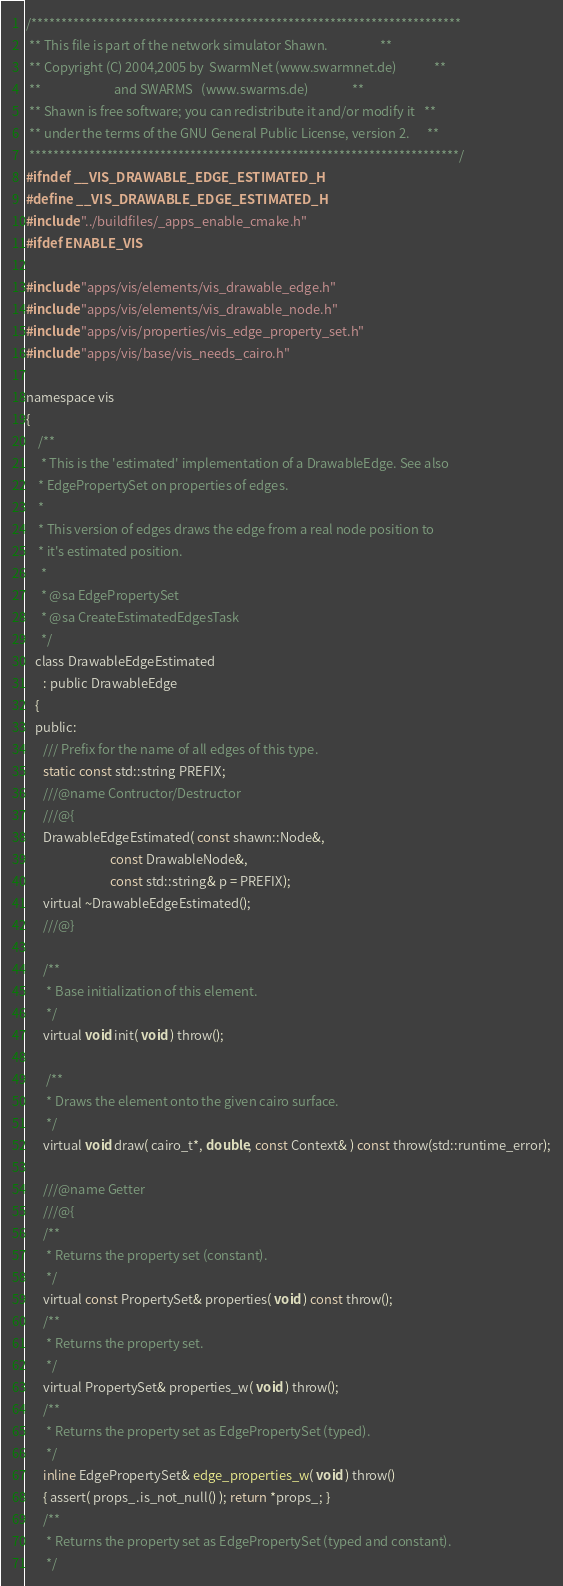Convert code to text. <code><loc_0><loc_0><loc_500><loc_500><_C_>/************************************************************************
 ** This file is part of the network simulator Shawn.                  **
 ** Copyright (C) 2004,2005 by  SwarmNet (www.swarmnet.de)             **
 **                         and SWARMS   (www.swarms.de)               **
 ** Shawn is free software; you can redistribute it and/or modify it   **
 ** under the terms of the GNU General Public License, version 2.      **
 ************************************************************************/
#ifndef __VIS_DRAWABLE_EDGE_ESTIMATED_H
#define __VIS_DRAWABLE_EDGE_ESTIMATED_H
#include "../buildfiles/_apps_enable_cmake.h"
#ifdef ENABLE_VIS

#include "apps/vis/elements/vis_drawable_edge.h"
#include "apps/vis/elements/vis_drawable_node.h"
#include "apps/vis/properties/vis_edge_property_set.h"
#include "apps/vis/base/vis_needs_cairo.h"

namespace vis
{
	/**
	 * This is the 'estimated' implementation of a DrawableEdge. See also 
    * EdgePropertySet on properties of edges. 
    *
    * This version of edges draws the edge from a real node position to
    * it's estimated position.
	 *
	 * @sa EdgePropertySet
	 * @sa CreateEstimatedEdgesTask
	 */
   class DrawableEdgeEstimated
      : public DrawableEdge
   {
   public:
      /// Prefix for the name of all edges of this type.
      static const std::string PREFIX;
      ///@name Contructor/Destructor
      ///@{
      DrawableEdgeEstimated( const shawn::Node&,
                             const DrawableNode&,
                             const std::string& p = PREFIX);
      virtual ~DrawableEdgeEstimated();
      ///@}

      /**
       * Base initialization of this element.
       */
      virtual void init( void ) throw();

	   /**
       * Draws the element onto the given cairo surface.
       */
      virtual void draw( cairo_t*, double, const Context& ) const throw(std::runtime_error);

      ///@name Getter
      ///@{
      /**
       * Returns the property set (constant).
       */
      virtual const PropertySet& properties( void ) const throw();
      /**
       * Returns the property set.
       */
      virtual PropertySet& properties_w( void ) throw();
      /**
       * Returns the property set as EdgePropertySet (typed).
       */
      inline EdgePropertySet& edge_properties_w( void ) throw()
      { assert( props_.is_not_null() ); return *props_; }
      /**
       * Returns the property set as EdgePropertySet (typed and constant).
       */</code> 